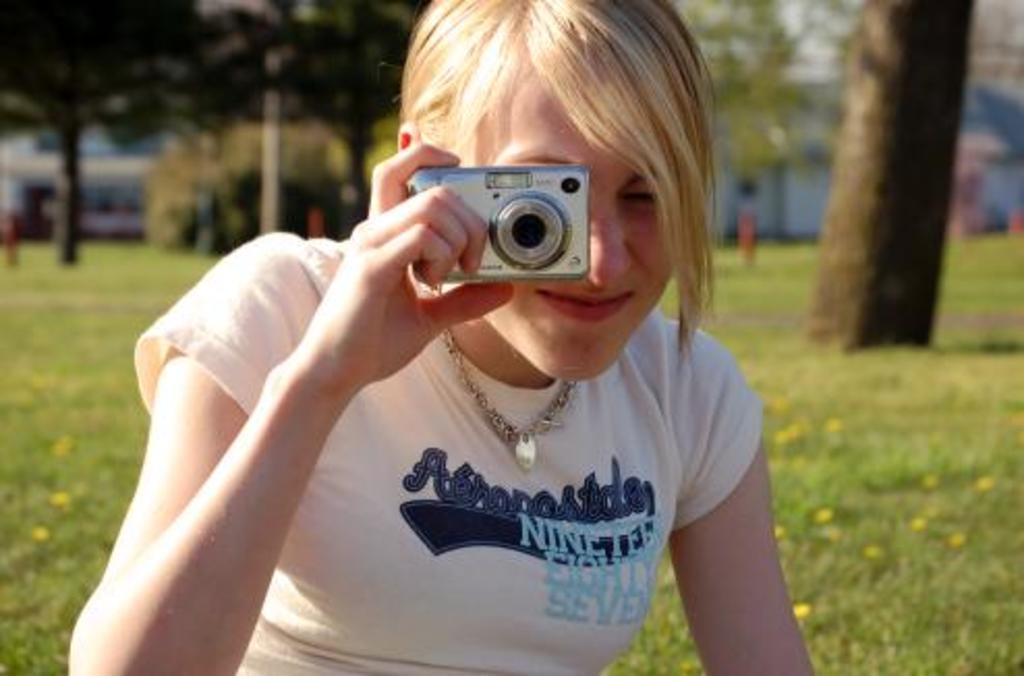What is the setting of the image? The image is of the outside. Who is the main subject in the image? There is a woman in the center of the image. What is the woman doing in the image? The woman is holding a camera and taking pictures. What can be seen in the background of the image? There are trees and green grass in the background of the image. Is there a rainstorm happening in the image? No, there is no rainstorm present in the image. What type of earthquake can be seen in the image? There is no earthquake depicted in the image. 